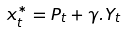<formula> <loc_0><loc_0><loc_500><loc_500>x _ { t } ^ { * } = P _ { t } + \gamma . Y _ { t }</formula> 